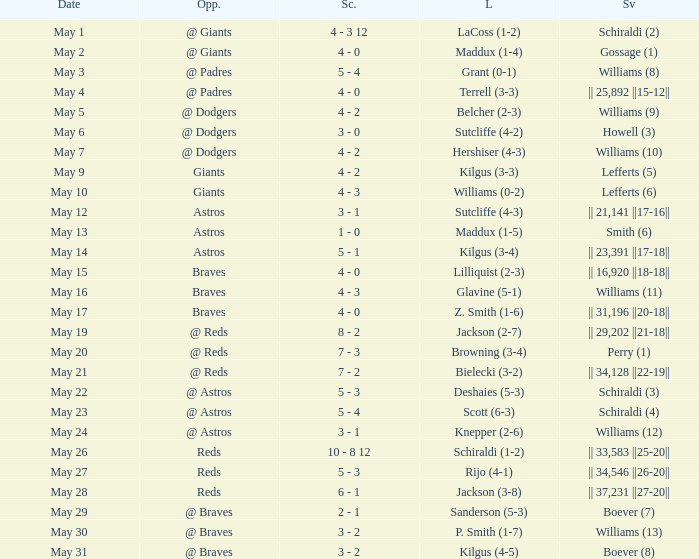Name the save for braves for may 15 || 16,920 ||18-18||. 